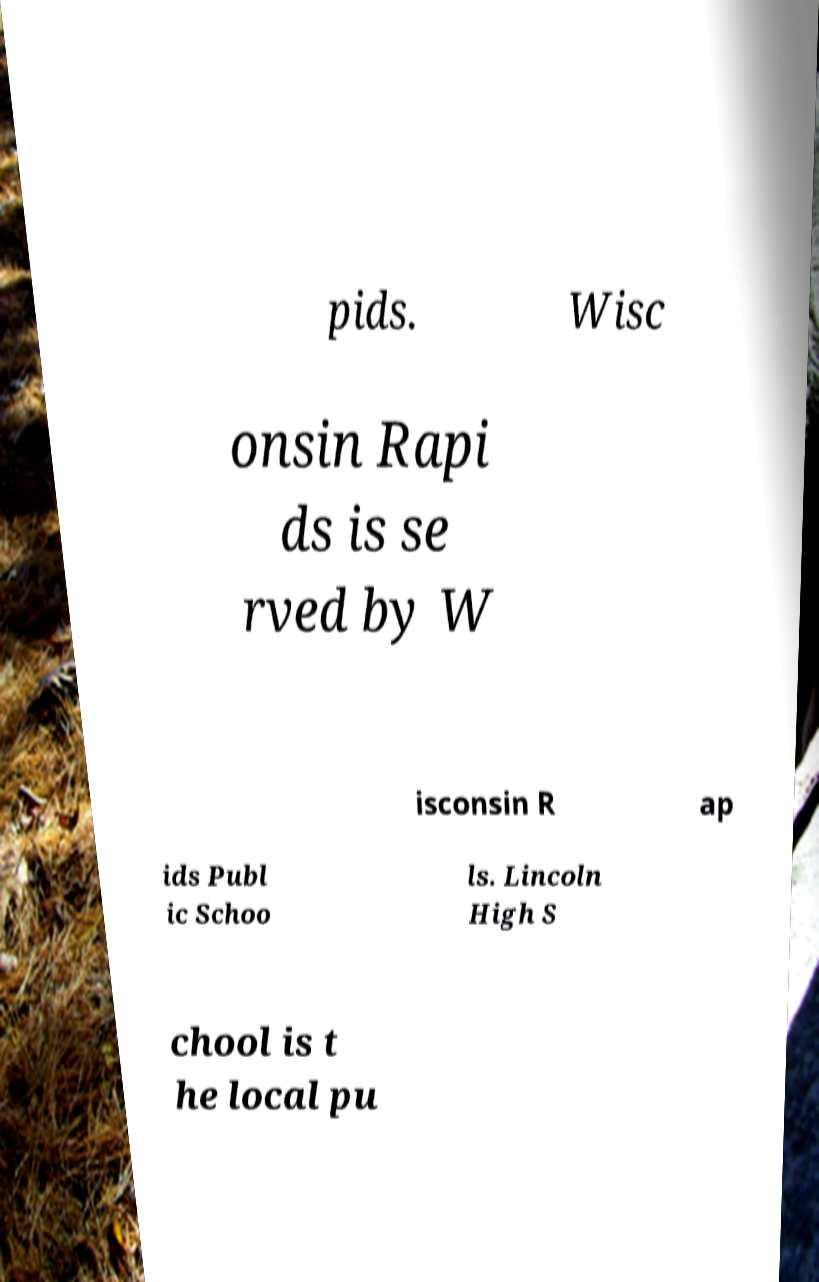Please identify and transcribe the text found in this image. pids. Wisc onsin Rapi ds is se rved by W isconsin R ap ids Publ ic Schoo ls. Lincoln High S chool is t he local pu 